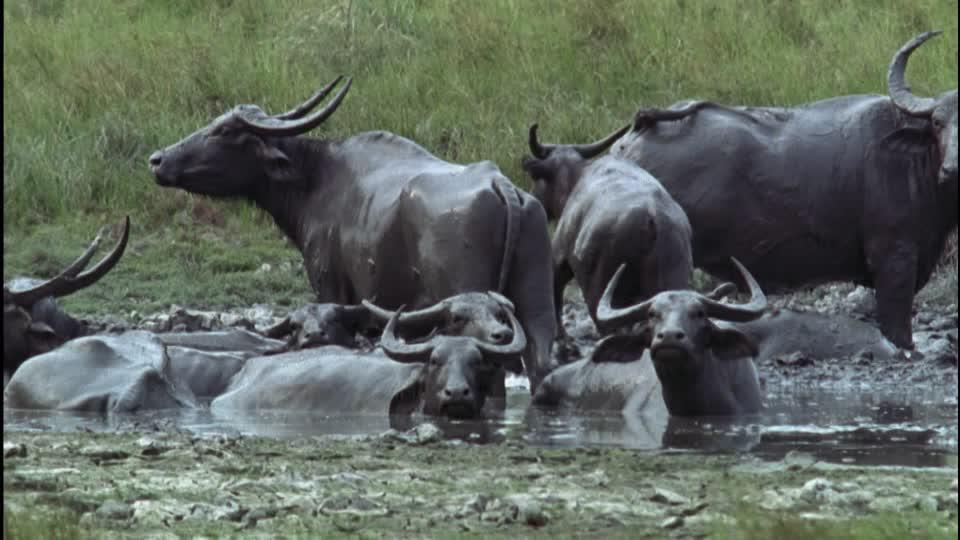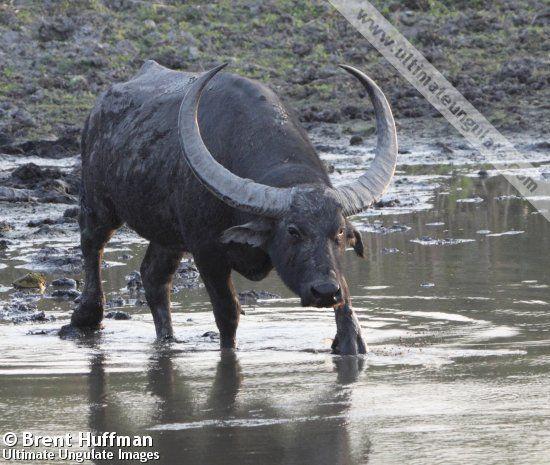The first image is the image on the left, the second image is the image on the right. Given the left and right images, does the statement "there are 2 bulls" hold true? Answer yes or no. No. 